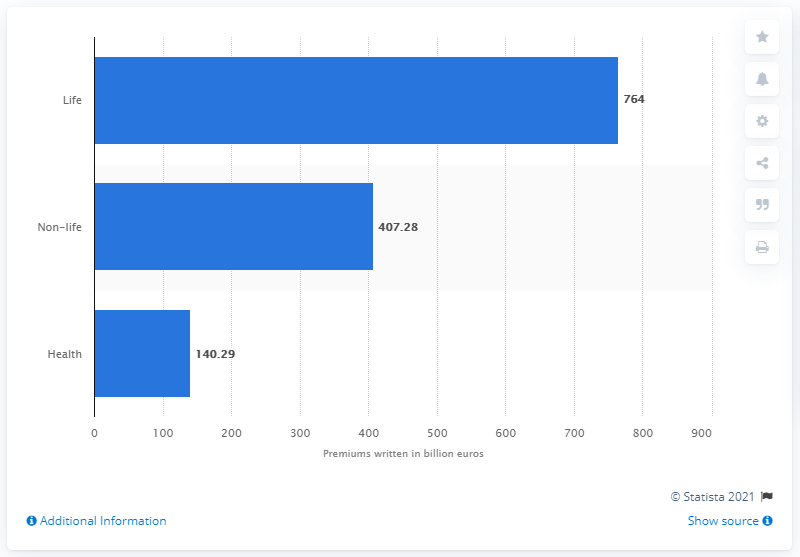Highlight a few significant elements in this photo. In 2018, the gross written premiums for life insurance were 764. The non-life insurance sector was valued at 407.28 billion in 2018. 